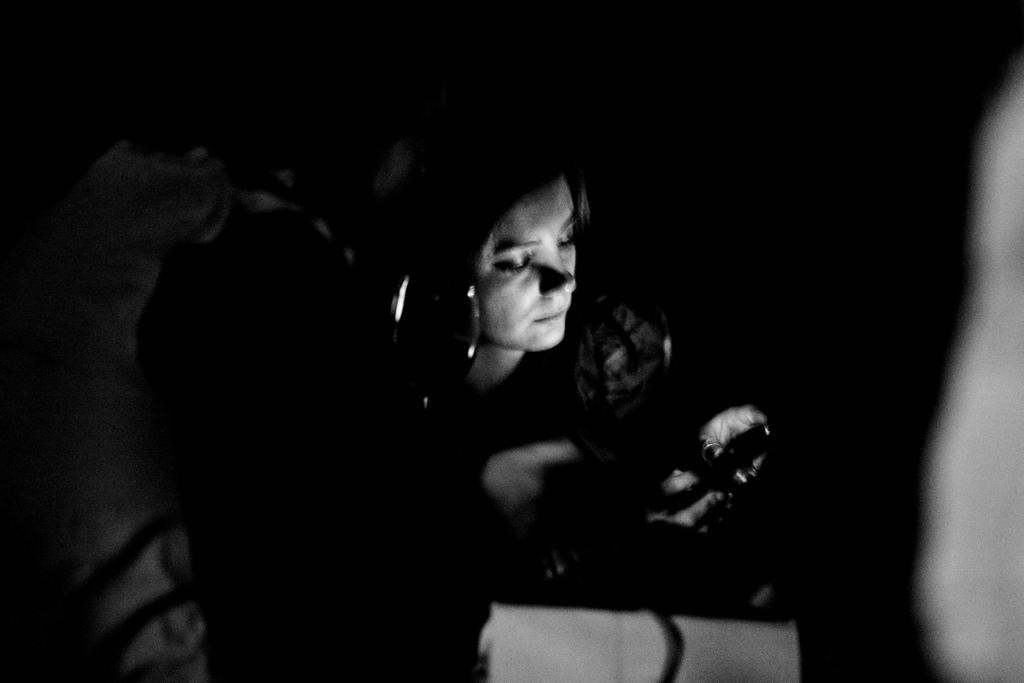What is the main subject of the image? There is a person's face in the image. What color is the background of the image? The background of the image is black. What type of yak can be seen in the image? There is no yak present in the image; it features a person's face. What is the person writing in the image? There is no indication that the person is writing in the image, as it only shows their face. 